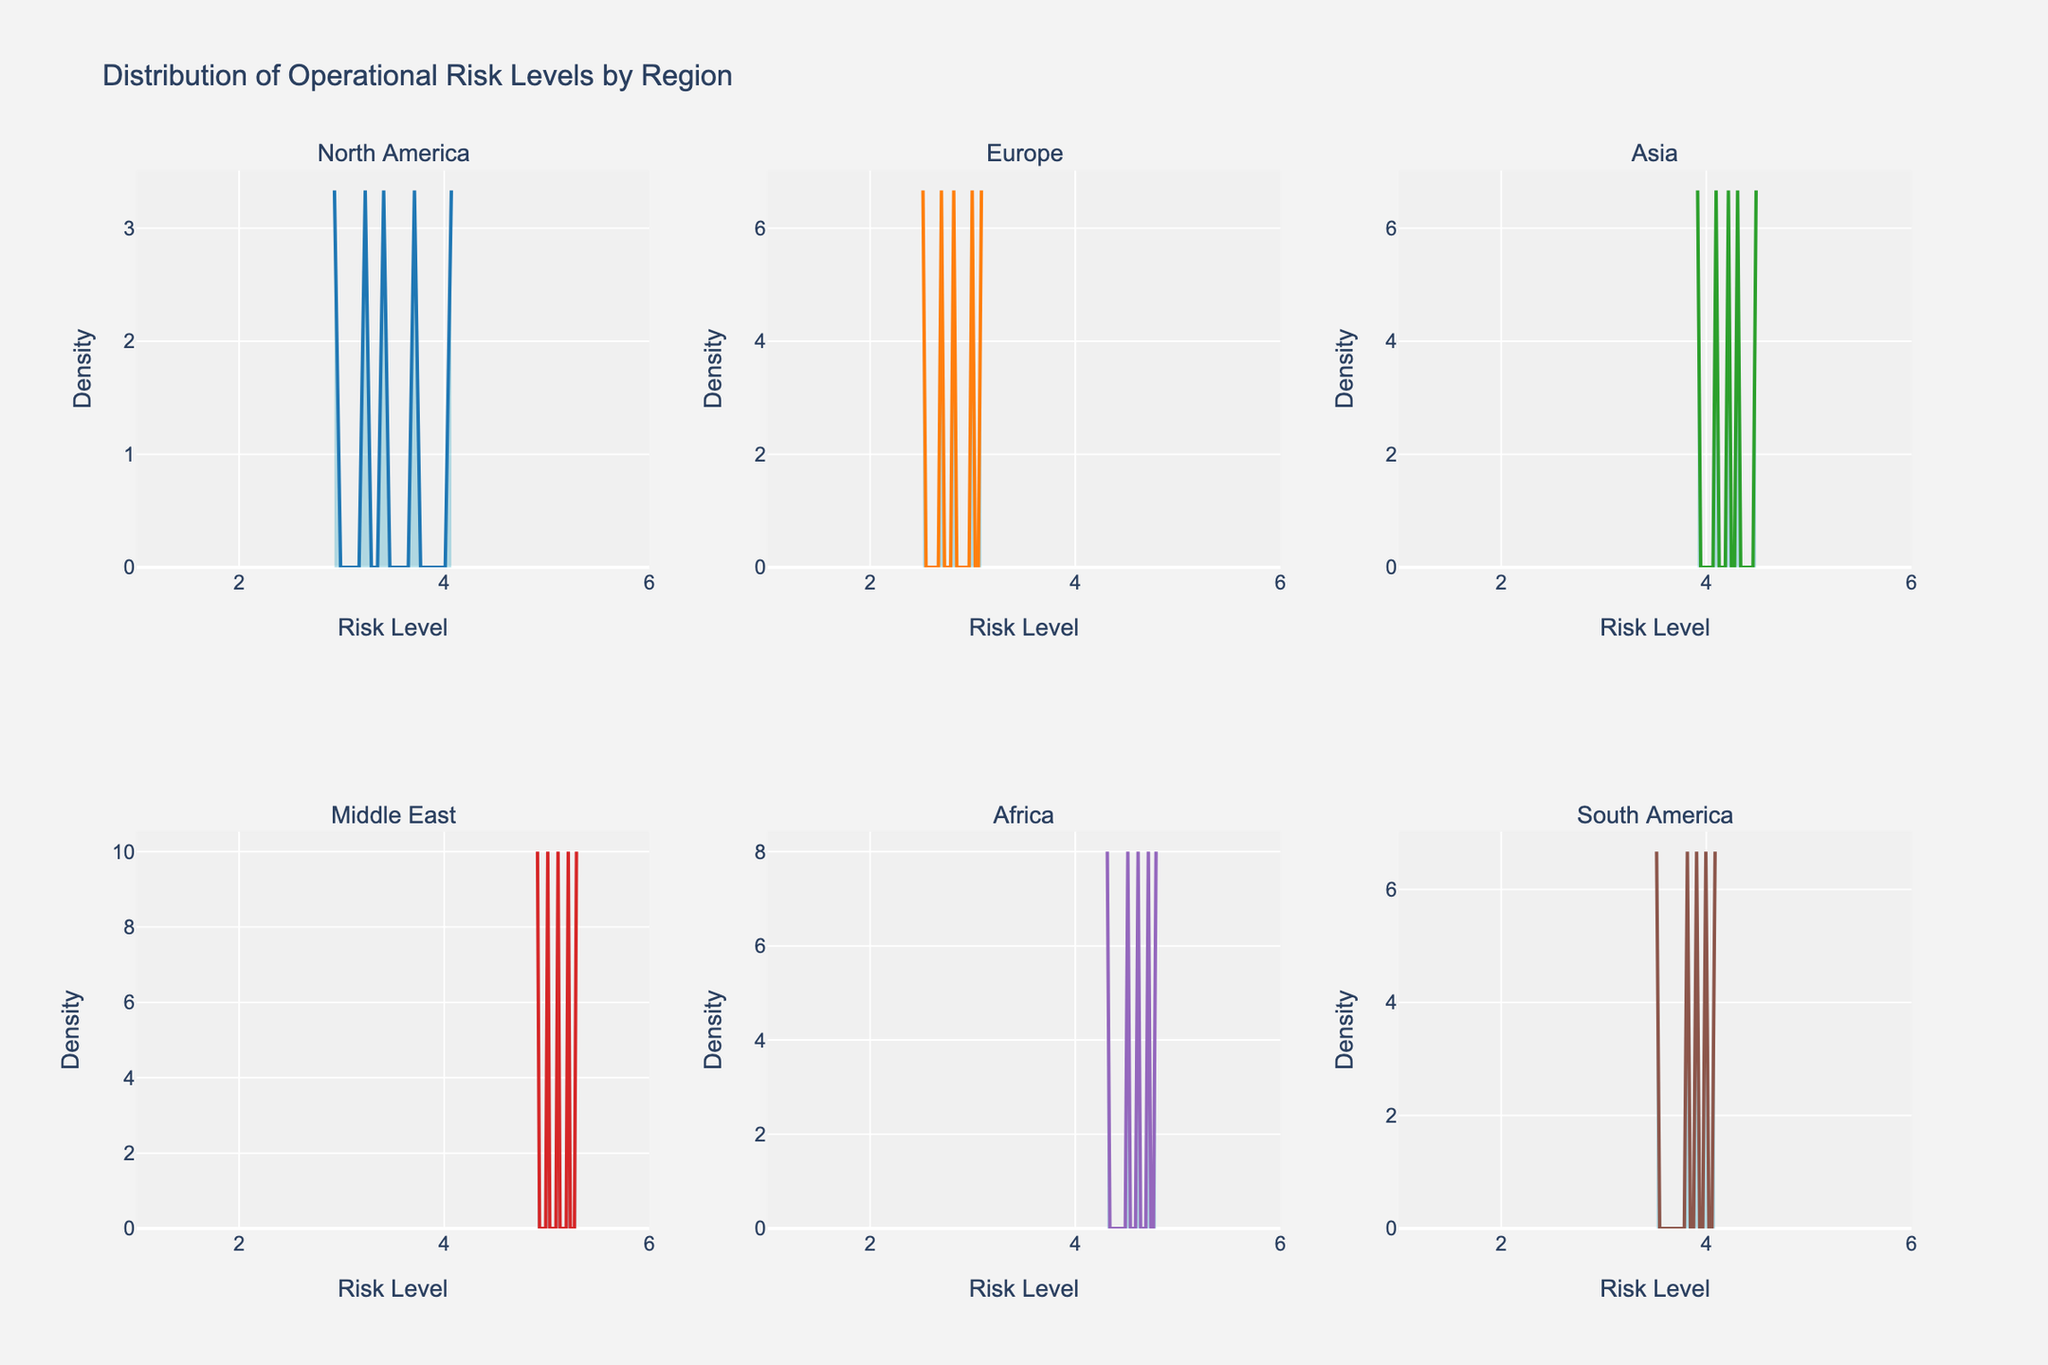Which region has the highest peak density of operational risk levels? The Middle East has the highest peak density because its density distribution reaches the highest value on the y-axis.
Answer: Middle East How does the average operational risk level in Asia compare to that in Europe? Asia has a higher average operational risk level. The peak density in Asia is centered around higher risk levels (4.0-4.5), while Europe's peak density centers around lower risk levels (2.5-3.0).
Answer: Asia has a higher average What is the range of risk levels depicted on the x-axis for all regions? The x-axis for all regions ranges from 1 to 6, as shown by the labels and the range of the x-axes.
Answer: 1 to 6 Which region has the widest distribution of operational risk levels? North America shows a relatively wide distribution in the figure with its density spread evenly across the risk levels from 2.9 to 4.1.
Answer: North America What is the common characteristic of the distribution shape for operational risk levels in all regions? All distributions show a unimodal shape, meaning each has a single peak, which reflects a common central tendency in each region.
Answer: Unimodal Which region has the lowest peak density of risk levels? Europe has the lowest peak density because it does not reach as high a value on the y-axis compared to other regions.
Answer: Europe In terms of risk distribution, how does Africa's density plot compare to South America's? Both Africa and South America display similar risk level distributions, but Africa's density is slightly higher and more concentrated around the middle range (4.5-4.7) compared to South America.
Answer: Africa has a slightly higher and more concentrated density What can we infer about the operational risk levels in the Middle East from the density plot? The Middle East has a consistently high risk level distribution almost entirely centered around the higher values (5.0-5.3), suggesting very high operational risks.
Answer: Very high operational risks 